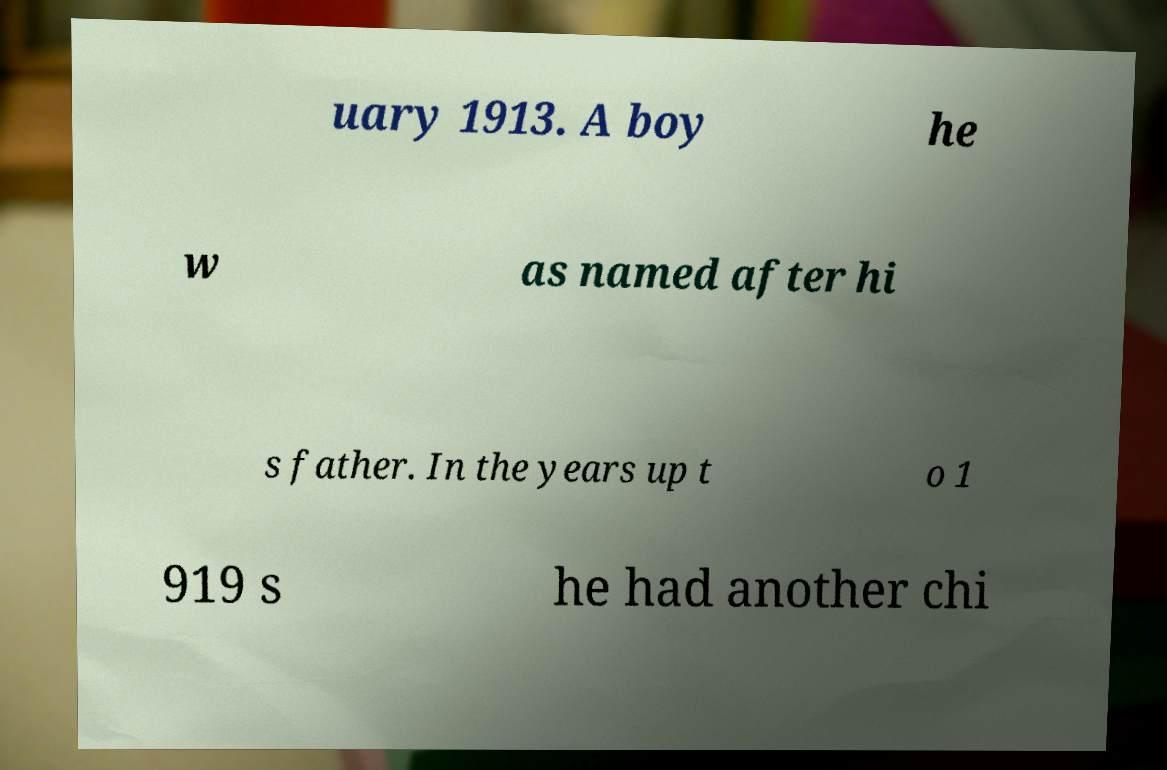Can you accurately transcribe the text from the provided image for me? uary 1913. A boy he w as named after hi s father. In the years up t o 1 919 s he had another chi 